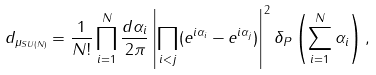Convert formula to latex. <formula><loc_0><loc_0><loc_500><loc_500>d _ { \mu _ { S U ( N ) } } = \frac { 1 } { N ! } \prod _ { i = 1 } ^ { N } \frac { d \alpha _ { i } } { 2 \pi } \left | \prod _ { i < j } ( e ^ { i \alpha _ { i } } - e ^ { i \alpha _ { j } } ) \right | ^ { 2 } \delta _ { P } \left ( \sum _ { i = 1 } ^ { N } \alpha _ { i } \right ) ,</formula> 